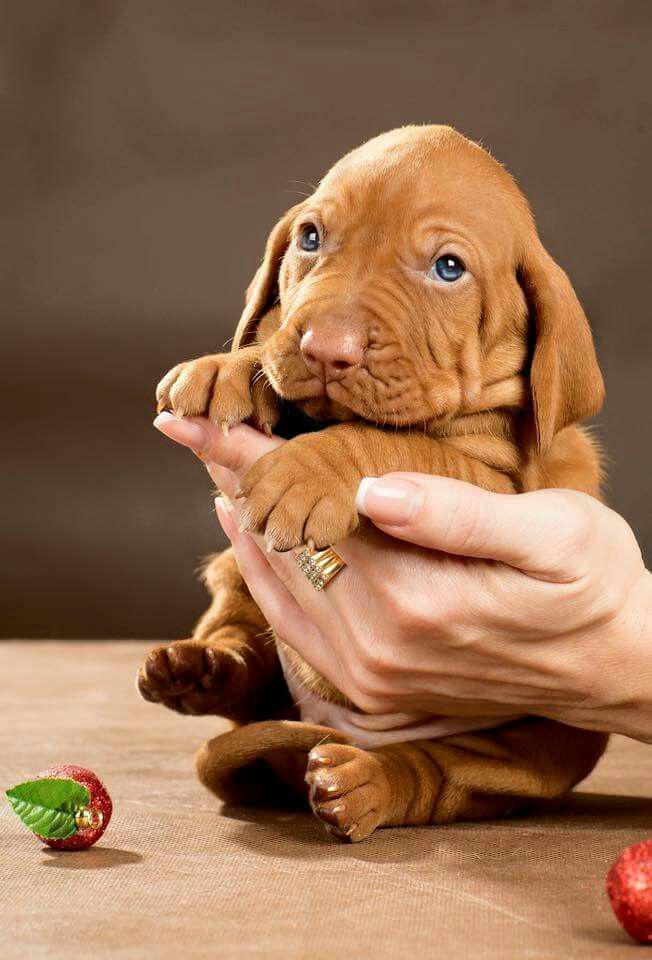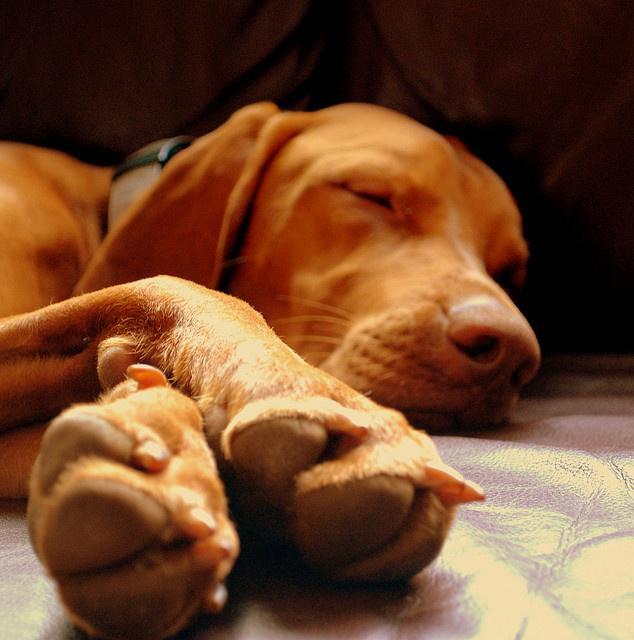The first image is the image on the left, the second image is the image on the right. Assess this claim about the two images: "The dog in the right image is sleeping.". Correct or not? Answer yes or no. Yes. The first image is the image on the left, the second image is the image on the right. For the images displayed, is the sentence "Each image contains a single dog, and the right image shows a sleeping hound with its head to the right." factually correct? Answer yes or no. Yes. 